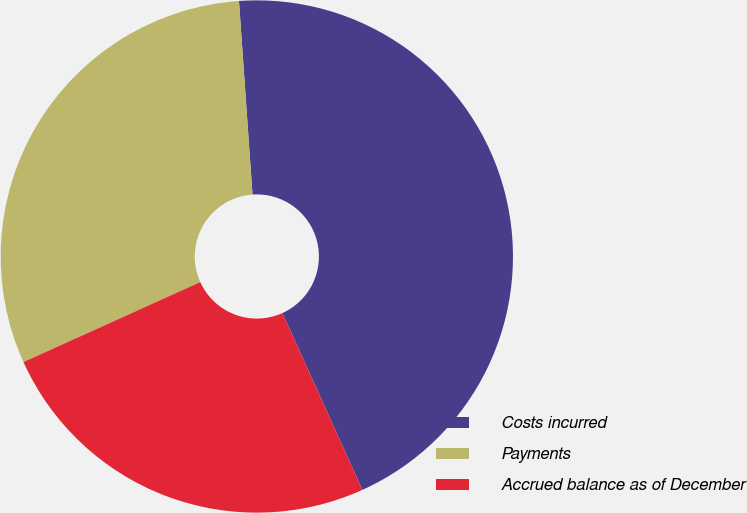<chart> <loc_0><loc_0><loc_500><loc_500><pie_chart><fcel>Costs incurred<fcel>Payments<fcel>Accrued balance as of December<nl><fcel>44.35%<fcel>30.65%<fcel>25.0%<nl></chart> 